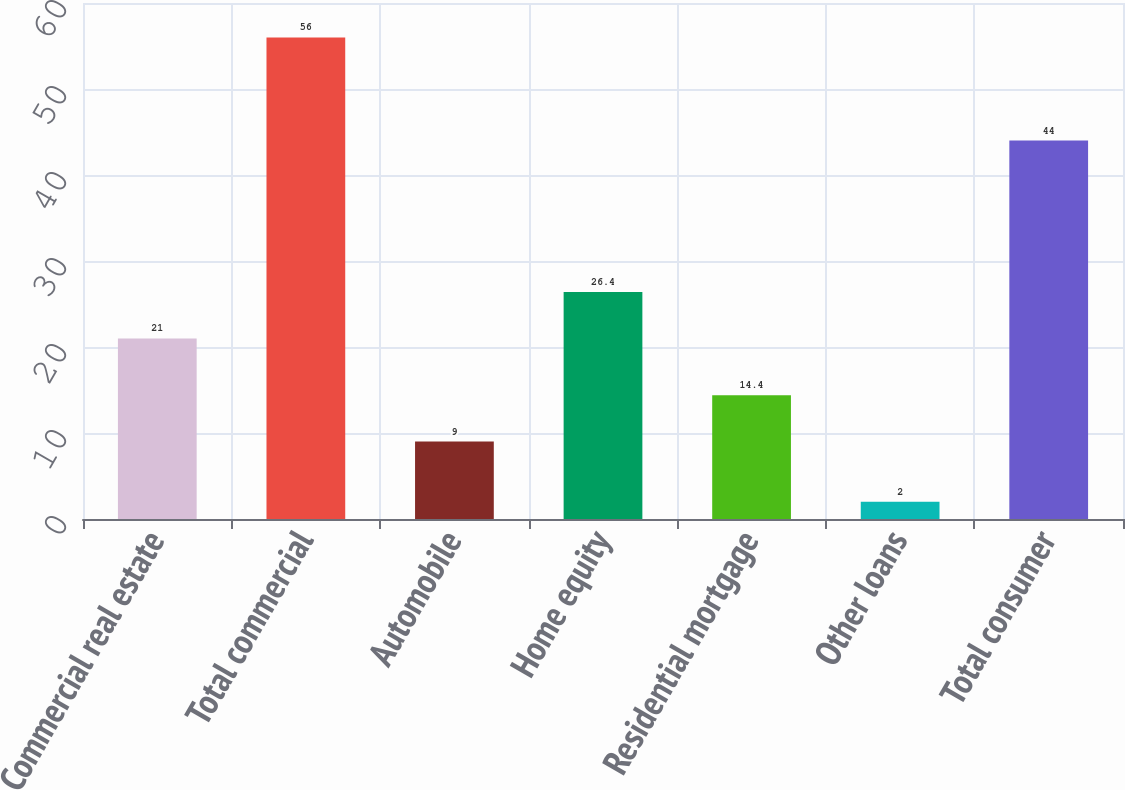Convert chart. <chart><loc_0><loc_0><loc_500><loc_500><bar_chart><fcel>Commercial real estate<fcel>Total commercial<fcel>Automobile<fcel>Home equity<fcel>Residential mortgage<fcel>Other loans<fcel>Total consumer<nl><fcel>21<fcel>56<fcel>9<fcel>26.4<fcel>14.4<fcel>2<fcel>44<nl></chart> 